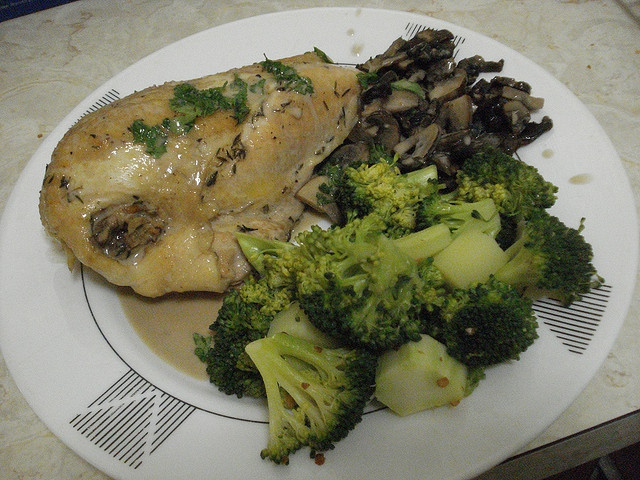Describe the objects in this image and their specific colors. I can see dining table in black, darkgray, tan, and gray tones, broccoli in black, darkgreen, and olive tones, broccoli in black, olive, darkgreen, and gray tones, broccoli in black, olive, and gray tones, and broccoli in black, olive, darkgreen, and gray tones in this image. 